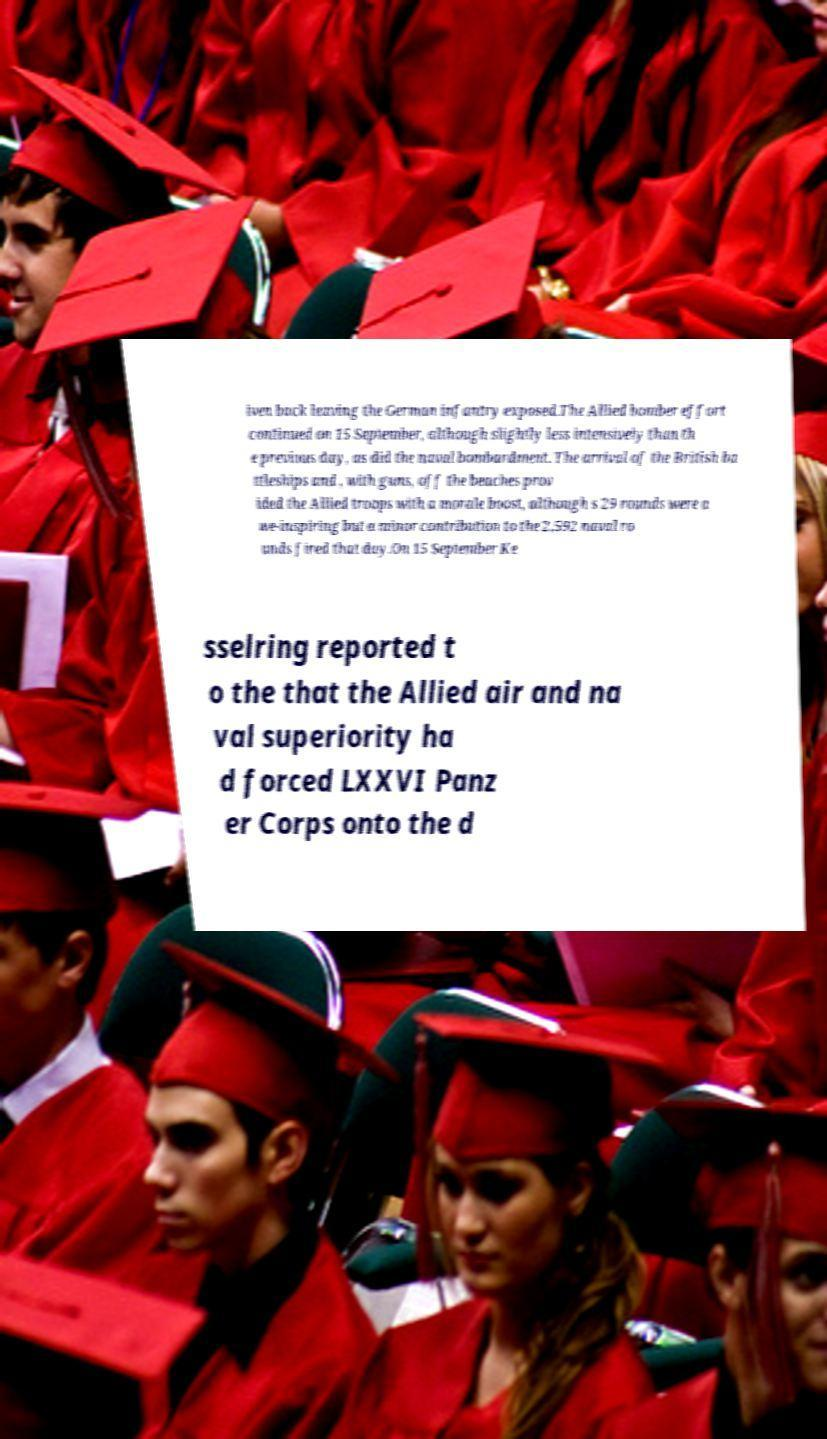There's text embedded in this image that I need extracted. Can you transcribe it verbatim? iven back leaving the German infantry exposed.The Allied bomber effort continued on 15 September, although slightly less intensively than th e previous day, as did the naval bombardment. The arrival of the British ba ttleships and , with guns, off the beaches prov ided the Allied troops with a morale boost, although s 29 rounds were a we-inspiring but a minor contribution to the 2,592 naval ro unds fired that day.On 15 September Ke sselring reported t o the that the Allied air and na val superiority ha d forced LXXVI Panz er Corps onto the d 